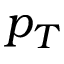<formula> <loc_0><loc_0><loc_500><loc_500>p _ { T }</formula> 